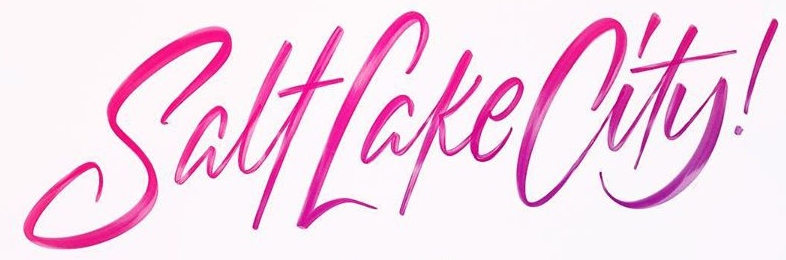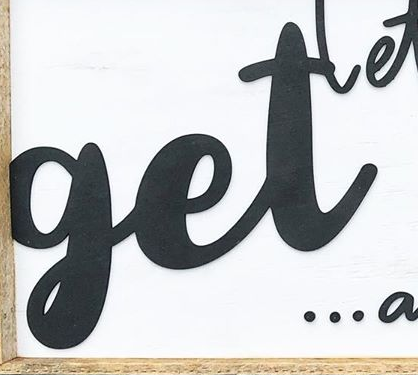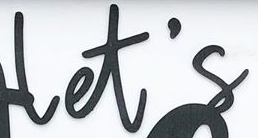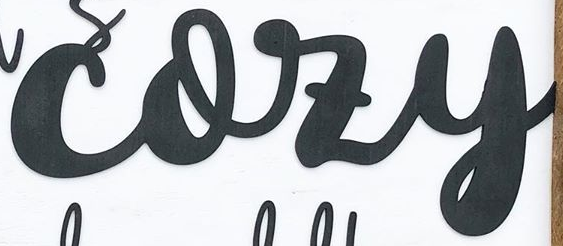Read the text content from these images in order, separated by a semicolon. SalfLakeCity!; get; let's; cozy 